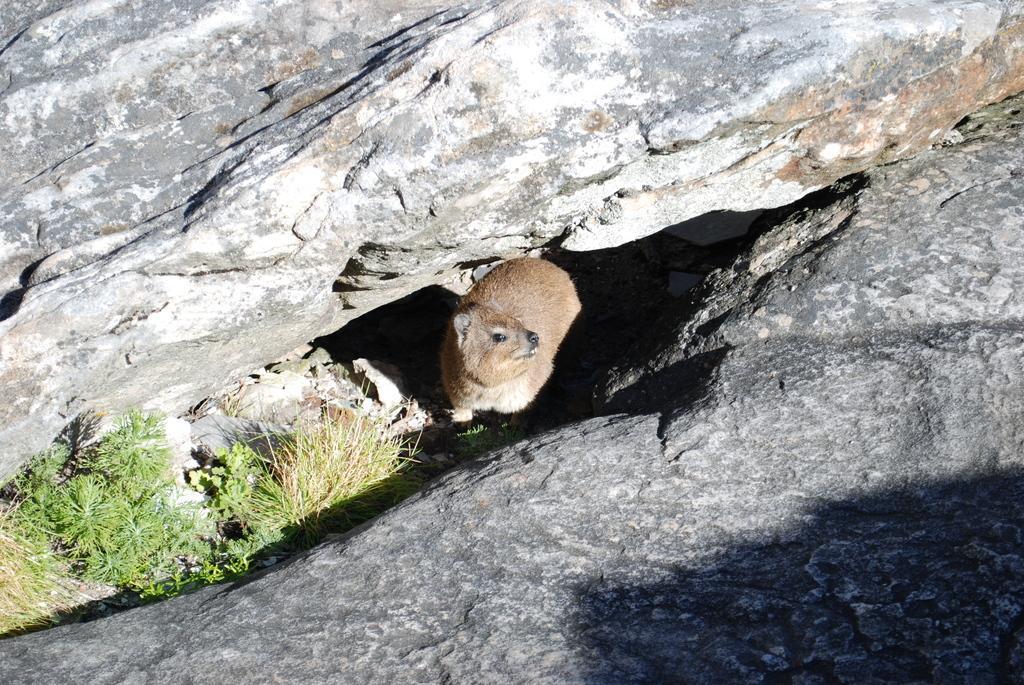Describe this image in one or two sentences. In this picture I can see an animal in between the rocks, and there is grass. 